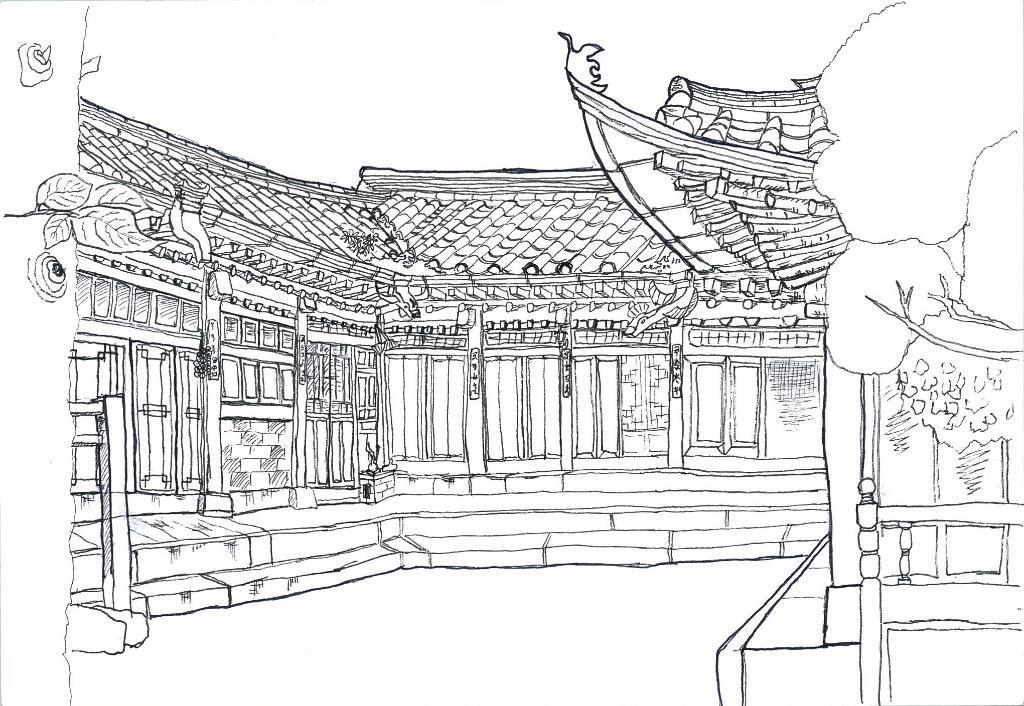What is depicted on the paper in the image? There is an art of a building on the paper. What color is the art on the paper? The art is in black color. Are there any fairies flying around the building in the art? There is no mention of fairies in the image, as the art only depicts a building. What side of the building is shown in the art? The art does not show a specific side of the building; it is a general representation of the building. 